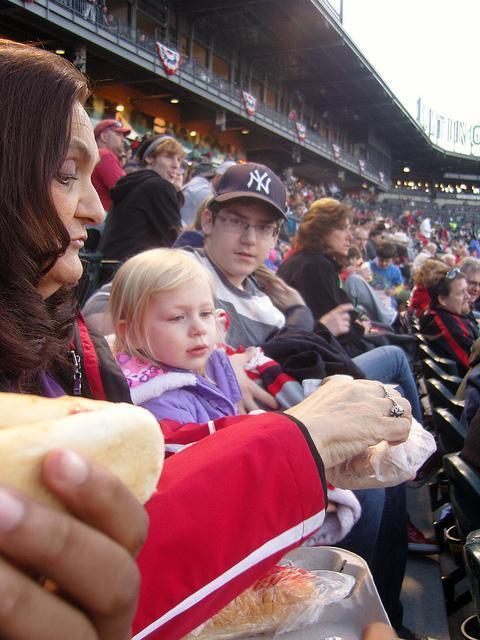How many people are in the photo?
Give a very brief answer. 7. How many hot dogs are in the photo?
Give a very brief answer. 3. 